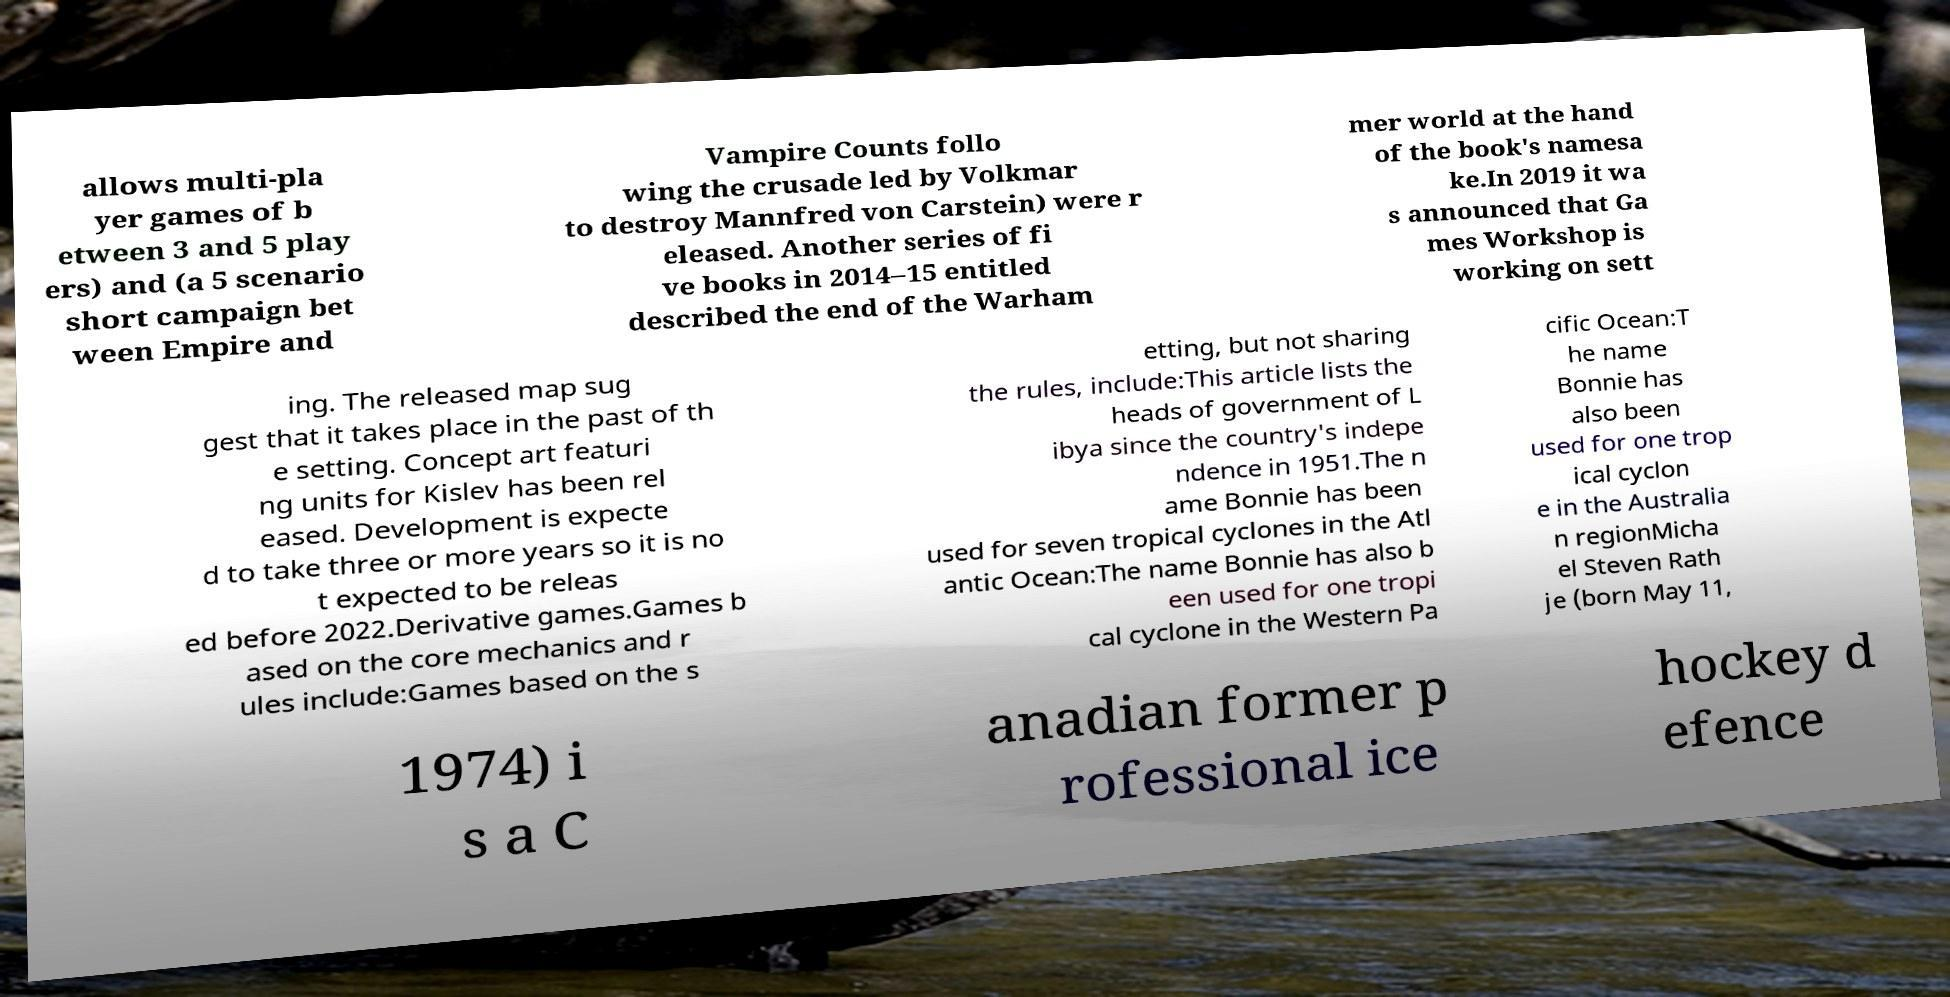Can you accurately transcribe the text from the provided image for me? allows multi-pla yer games of b etween 3 and 5 play ers) and (a 5 scenario short campaign bet ween Empire and Vampire Counts follo wing the crusade led by Volkmar to destroy Mannfred von Carstein) were r eleased. Another series of fi ve books in 2014–15 entitled described the end of the Warham mer world at the hand of the book's namesa ke.In 2019 it wa s announced that Ga mes Workshop is working on sett ing. The released map sug gest that it takes place in the past of th e setting. Concept art featuri ng units for Kislev has been rel eased. Development is expecte d to take three or more years so it is no t expected to be releas ed before 2022.Derivative games.Games b ased on the core mechanics and r ules include:Games based on the s etting, but not sharing the rules, include:This article lists the heads of government of L ibya since the country's indepe ndence in 1951.The n ame Bonnie has been used for seven tropical cyclones in the Atl antic Ocean:The name Bonnie has also b een used for one tropi cal cyclone in the Western Pa cific Ocean:T he name Bonnie has also been used for one trop ical cyclon e in the Australia n regionMicha el Steven Rath je (born May 11, 1974) i s a C anadian former p rofessional ice hockey d efence 